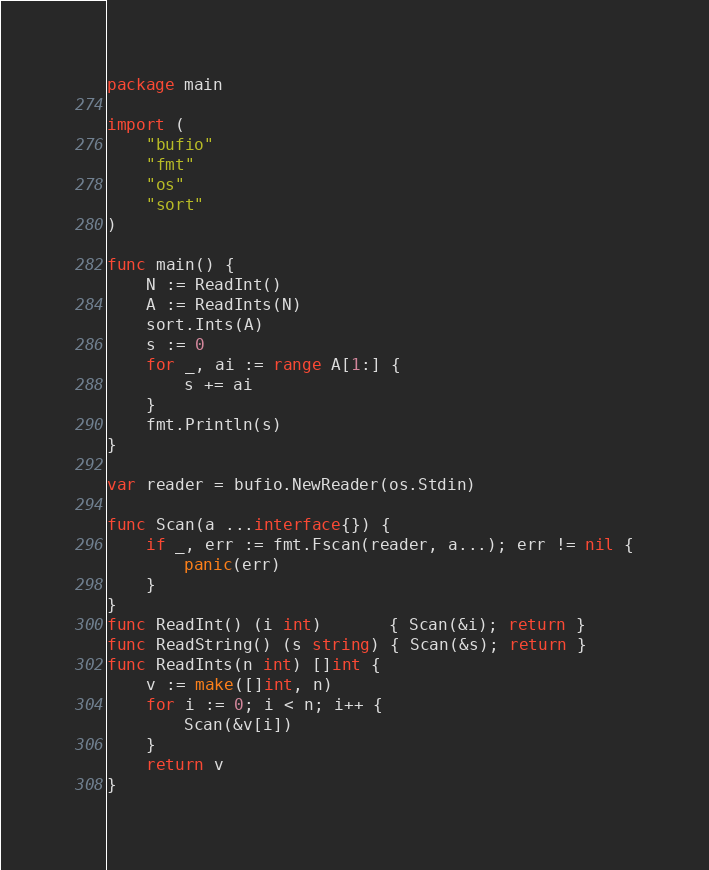<code> <loc_0><loc_0><loc_500><loc_500><_Go_>package main

import (
	"bufio"
	"fmt"
	"os"
	"sort"
)

func main() {
	N := ReadInt()
	A := ReadInts(N)
	sort.Ints(A)
	s := 0
	for _, ai := range A[1:] {
		s += ai
	}
	fmt.Println(s)
}

var reader = bufio.NewReader(os.Stdin)

func Scan(a ...interface{}) {
	if _, err := fmt.Fscan(reader, a...); err != nil {
		panic(err)
	}
}
func ReadInt() (i int)       { Scan(&i); return }
func ReadString() (s string) { Scan(&s); return }
func ReadInts(n int) []int {
	v := make([]int, n)
	for i := 0; i < n; i++ {
		Scan(&v[i])
	}
	return v
}
</code> 